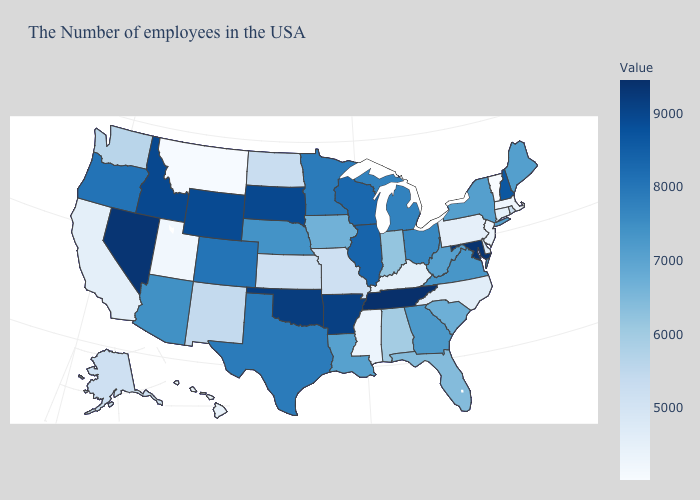Does the map have missing data?
Write a very short answer. No. Does Illinois have a lower value than Nebraska?
Keep it brief. No. Among the states that border Illinois , does Wisconsin have the highest value?
Concise answer only. Yes. Which states hav the highest value in the Northeast?
Concise answer only. New Hampshire. Which states have the lowest value in the South?
Write a very short answer. Mississippi. Does North Dakota have the lowest value in the MidWest?
Be succinct. No. Does New Mexico have a lower value than Oklahoma?
Write a very short answer. Yes. 